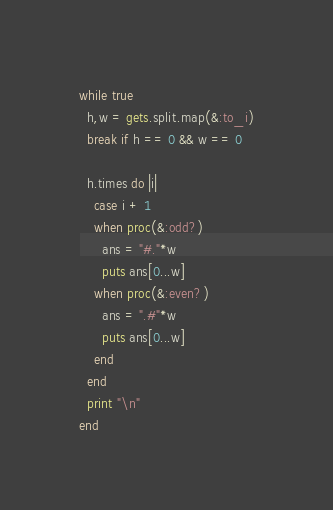<code> <loc_0><loc_0><loc_500><loc_500><_Ruby_>while true
  h,w = gets.split.map(&:to_i)
  break if h == 0 && w == 0

  h.times do |i|
    case i + 1
    when proc(&:odd?)
      ans = "#."*w
      puts ans[0...w]
    when proc(&:even?)
      ans = ".#"*w
      puts ans[0...w]
    end
  end
  print "\n"
end</code> 